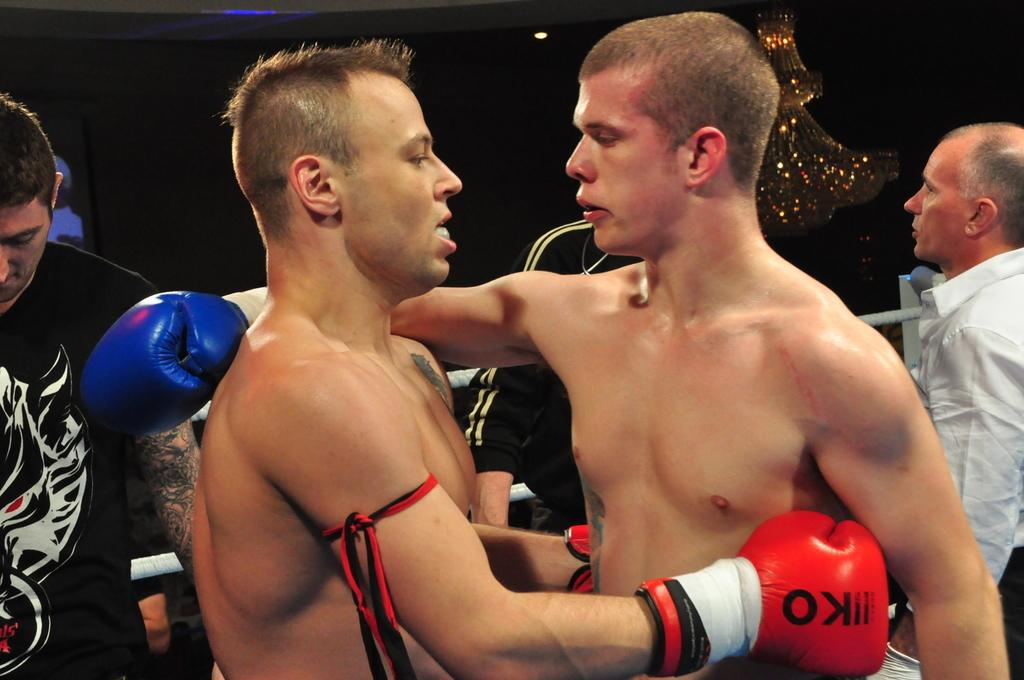Provide a one-sentence caption for the provided image. Two boxers embrace, and one of them is wearing a glove that says KO on it. 